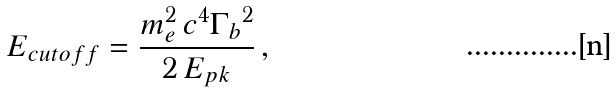<formula> <loc_0><loc_0><loc_500><loc_500>E _ { c u t o f f } = \frac { m _ { e } ^ { 2 } \, c ^ { 4 } { \Gamma _ { b } } ^ { 2 } } { 2 \, E _ { p k } } \, ,</formula> 